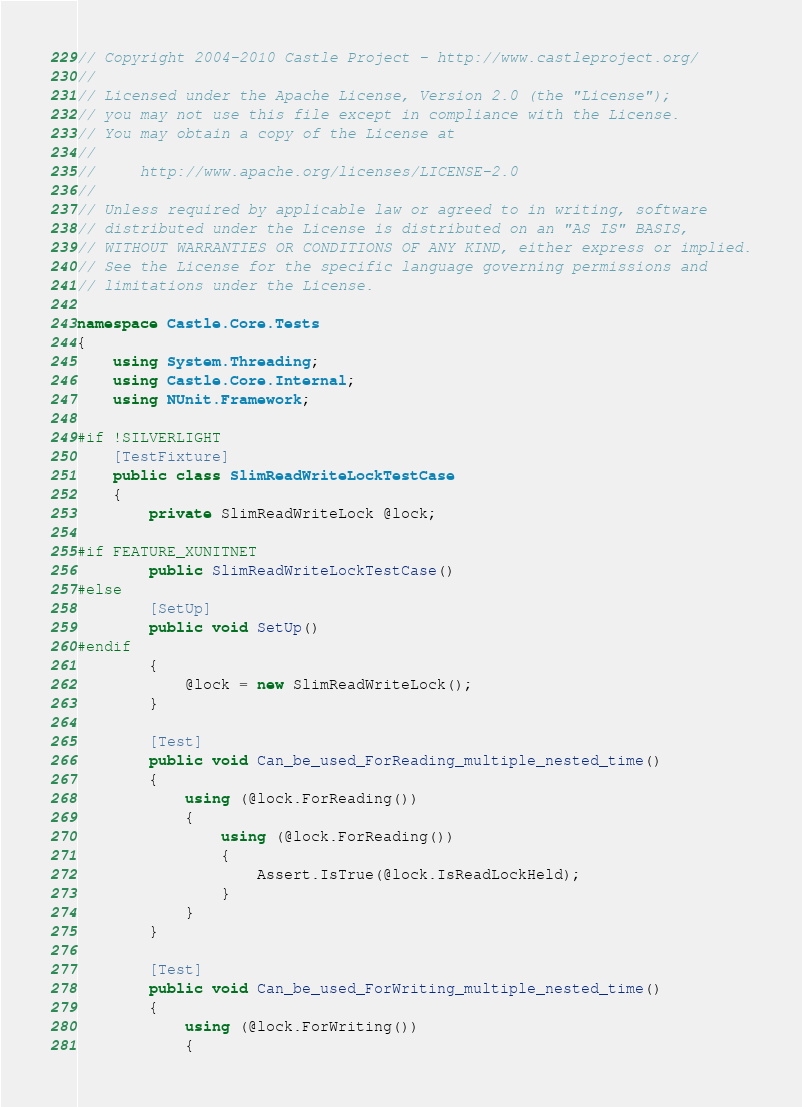Convert code to text. <code><loc_0><loc_0><loc_500><loc_500><_C#_>// Copyright 2004-2010 Castle Project - http://www.castleproject.org/
// 
// Licensed under the Apache License, Version 2.0 (the "License");
// you may not use this file except in compliance with the License.
// You may obtain a copy of the License at
// 
//     http://www.apache.org/licenses/LICENSE-2.0
// 
// Unless required by applicable law or agreed to in writing, software
// distributed under the License is distributed on an "AS IS" BASIS,
// WITHOUT WARRANTIES OR CONDITIONS OF ANY KIND, either express or implied.
// See the License for the specific language governing permissions and
// limitations under the License.

namespace Castle.Core.Tests
{
	using System.Threading;
	using Castle.Core.Internal;
	using NUnit.Framework;

#if !SILVERLIGHT
	[TestFixture]
	public class SlimReadWriteLockTestCase
	{
		private SlimReadWriteLock @lock;

#if FEATURE_XUNITNET
		public SlimReadWriteLockTestCase()
#else
		[SetUp]
		public void SetUp()
#endif
		{
			@lock = new SlimReadWriteLock();
		}

		[Test]
		public void Can_be_used_ForReading_multiple_nested_time()
		{
			using (@lock.ForReading())
			{
				using (@lock.ForReading())
				{
					Assert.IsTrue(@lock.IsReadLockHeld);
				}
			}
		}

		[Test]
		public void Can_be_used_ForWriting_multiple_nested_time()
		{
			using (@lock.ForWriting())
			{</code> 